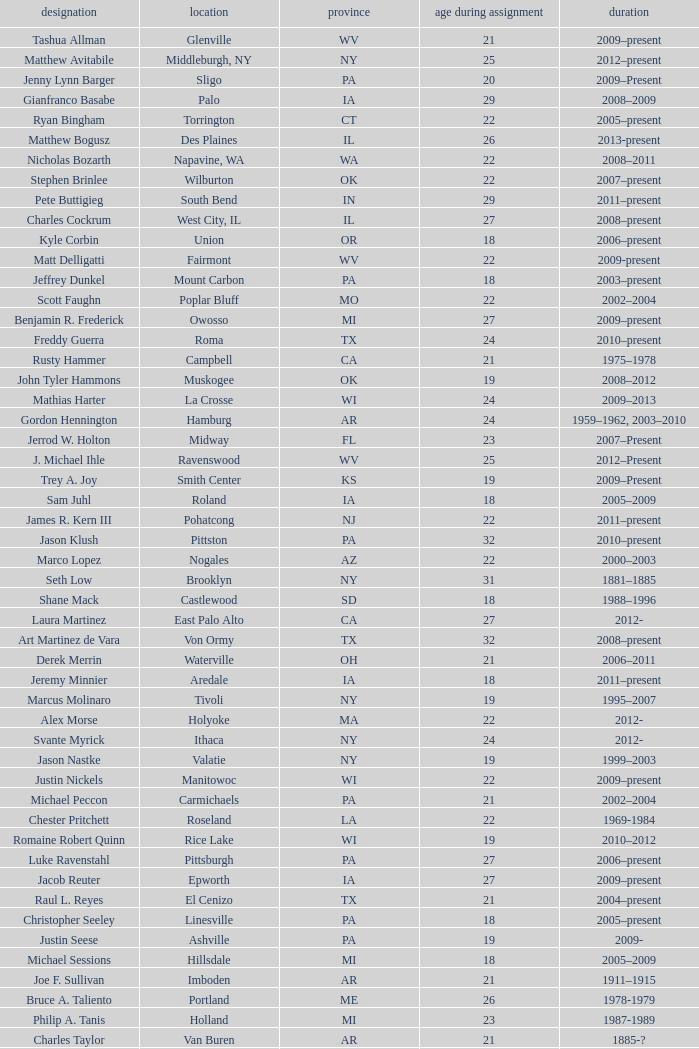What is the name of the holland locale Philip A. Tanis. 